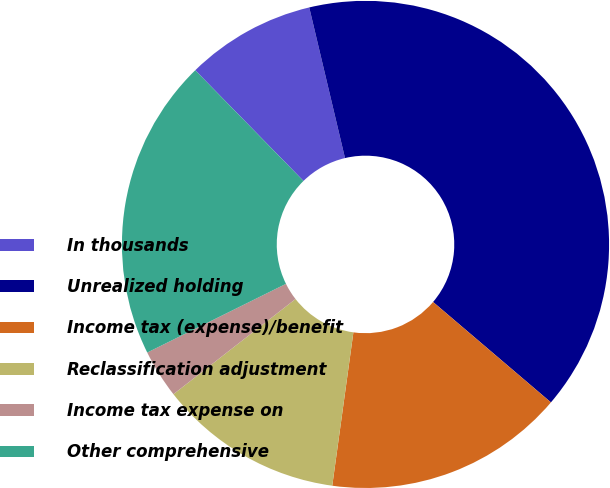<chart> <loc_0><loc_0><loc_500><loc_500><pie_chart><fcel>In thousands<fcel>Unrealized holding<fcel>Income tax (expense)/benefit<fcel>Reclassification adjustment<fcel>Income tax expense on<fcel>Other comprehensive<nl><fcel>8.61%<fcel>39.94%<fcel>15.95%<fcel>12.28%<fcel>3.22%<fcel>20.0%<nl></chart> 